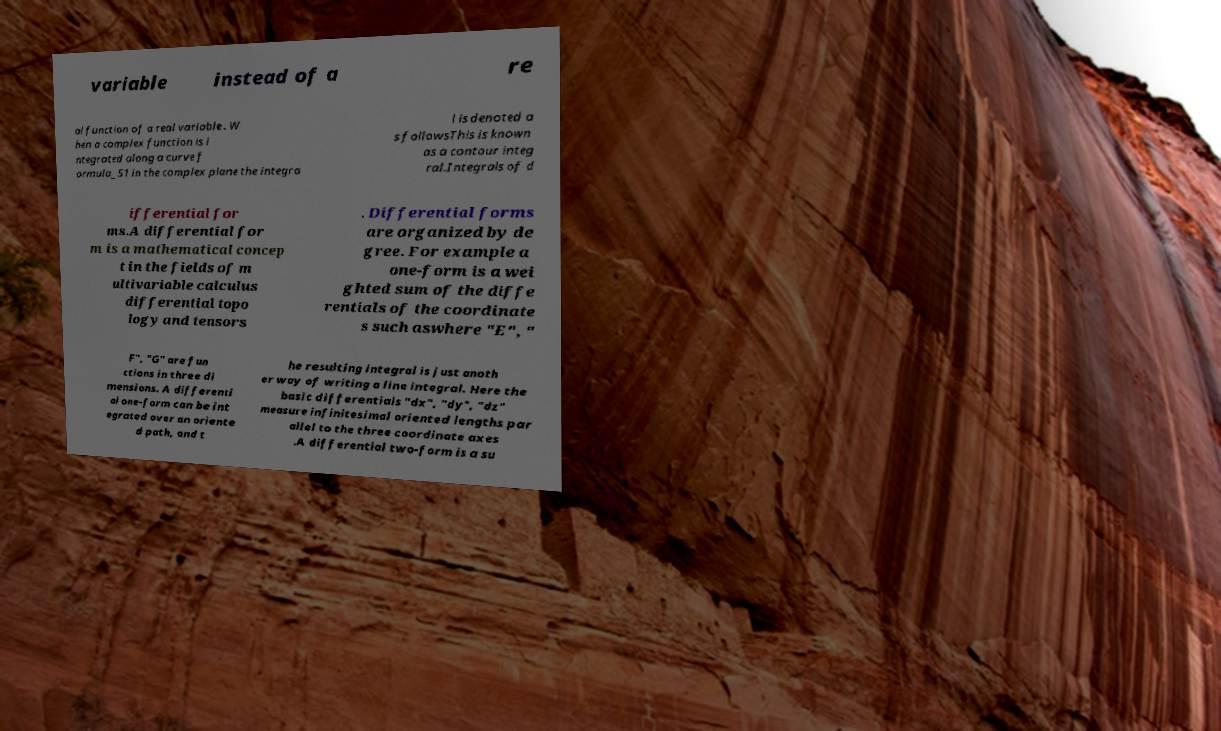Can you read and provide the text displayed in the image?This photo seems to have some interesting text. Can you extract and type it out for me? variable instead of a re al function of a real variable . W hen a complex function is i ntegrated along a curve f ormula_51 in the complex plane the integra l is denoted a s followsThis is known as a contour integ ral.Integrals of d ifferential for ms.A differential for m is a mathematical concep t in the fields of m ultivariable calculus differential topo logy and tensors . Differential forms are organized by de gree. For example a one-form is a wei ghted sum of the diffe rentials of the coordinate s such aswhere "E", " F", "G" are fun ctions in three di mensions. A differenti al one-form can be int egrated over an oriente d path, and t he resulting integral is just anoth er way of writing a line integral. Here the basic differentials "dx", "dy", "dz" measure infinitesimal oriented lengths par allel to the three coordinate axes .A differential two-form is a su 